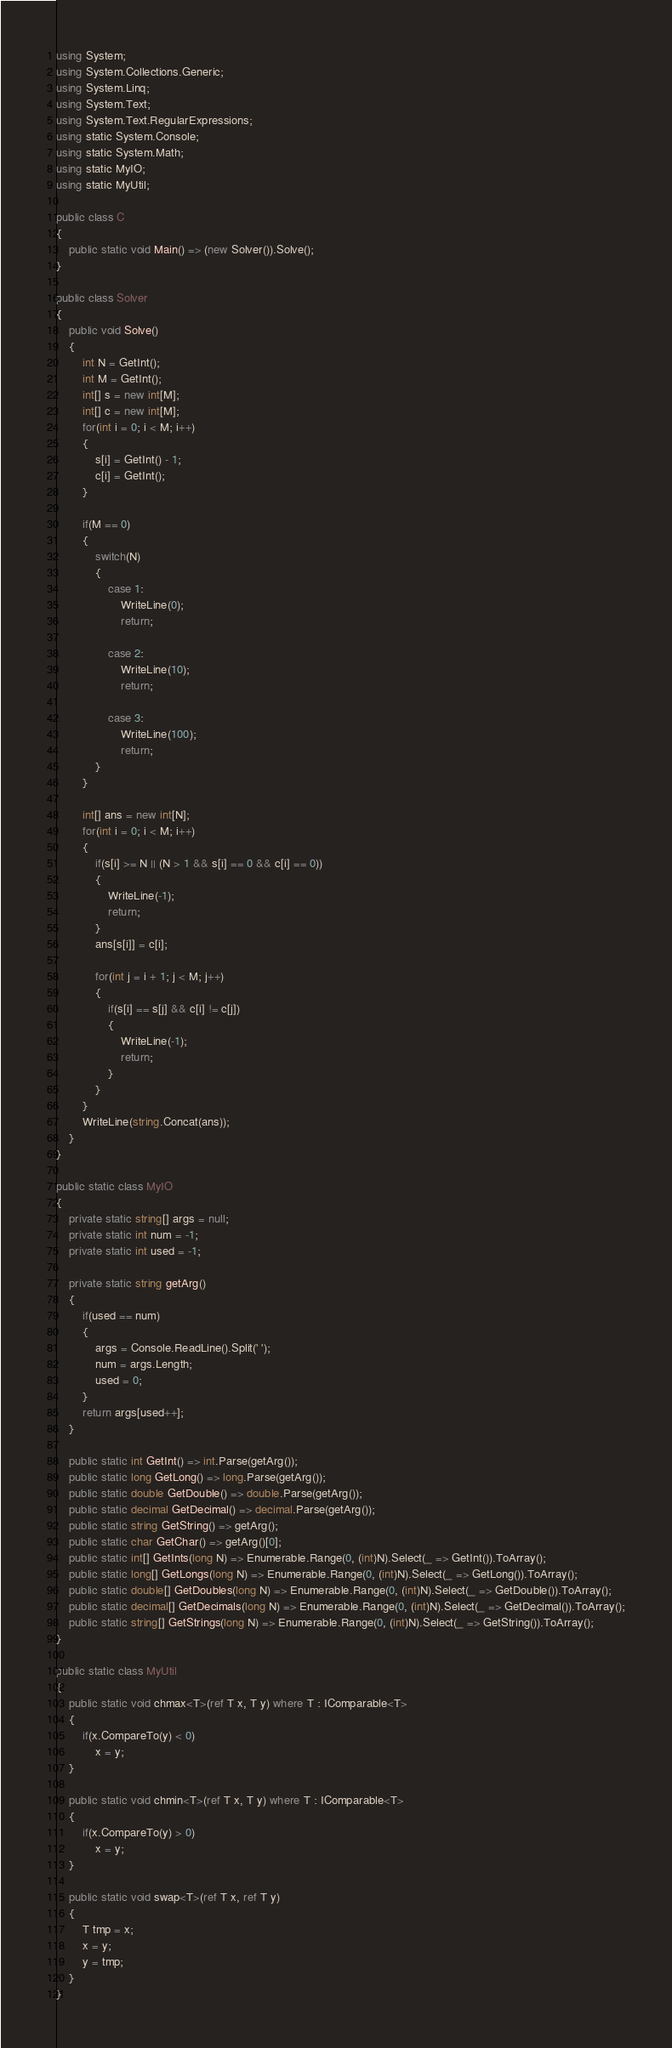<code> <loc_0><loc_0><loc_500><loc_500><_C#_>using System;
using System.Collections.Generic;
using System.Linq;
using System.Text;
using System.Text.RegularExpressions;
using static System.Console;
using static System.Math;
using static MyIO;
using static MyUtil;

public class C
{
	public static void Main() => (new Solver()).Solve();
}

public class Solver
{
	public void Solve()
	{
		int N = GetInt();
		int M = GetInt();
		int[] s = new int[M];
		int[] c = new int[M];
		for(int i = 0; i < M; i++)
		{
			s[i] = GetInt() - 1;
			c[i] = GetInt();
		}

		if(M == 0)
		{
			switch(N)
			{
				case 1:
					WriteLine(0);
					return;

				case 2:
					WriteLine(10);
					return;

				case 3:
					WriteLine(100);
					return;
			}
		}

		int[] ans = new int[N];
		for(int i = 0; i < M; i++)
		{
			if(s[i] >= N || (N > 1 && s[i] == 0 && c[i] == 0))
			{
				WriteLine(-1);
				return;
			}
			ans[s[i]] = c[i];

			for(int j = i + 1; j < M; j++)
			{
				if(s[i] == s[j] && c[i] != c[j])
				{
					WriteLine(-1);
					return;
				}
			}
		}
		WriteLine(string.Concat(ans));
	}
}

public static class MyIO
{
	private static string[] args = null;
	private static int num = -1;
	private static int used = -1;

	private static string getArg()
	{
		if(used == num)
		{
			args = Console.ReadLine().Split(' ');
			num = args.Length;
			used = 0;
		}
		return args[used++];
	}

	public static int GetInt() => int.Parse(getArg());
	public static long GetLong() => long.Parse(getArg());
	public static double GetDouble() => double.Parse(getArg());
	public static decimal GetDecimal() => decimal.Parse(getArg());
	public static string GetString() => getArg();
	public static char GetChar() => getArg()[0];
	public static int[] GetInts(long N) => Enumerable.Range(0, (int)N).Select(_ => GetInt()).ToArray();
	public static long[] GetLongs(long N) => Enumerable.Range(0, (int)N).Select(_ => GetLong()).ToArray();
	public static double[] GetDoubles(long N) => Enumerable.Range(0, (int)N).Select(_ => GetDouble()).ToArray();
	public static decimal[] GetDecimals(long N) => Enumerable.Range(0, (int)N).Select(_ => GetDecimal()).ToArray();
	public static string[] GetStrings(long N) => Enumerable.Range(0, (int)N).Select(_ => GetString()).ToArray();
}

public static class MyUtil
{
	public static void chmax<T>(ref T x, T y) where T : IComparable<T>
	{
		if(x.CompareTo(y) < 0)
			x = y;
	}

	public static void chmin<T>(ref T x, T y) where T : IComparable<T>
	{
		if(x.CompareTo(y) > 0)
			x = y;
	}

	public static void swap<T>(ref T x, ref T y)
	{
		T tmp = x;
		x = y;
		y = tmp;
	}
}</code> 